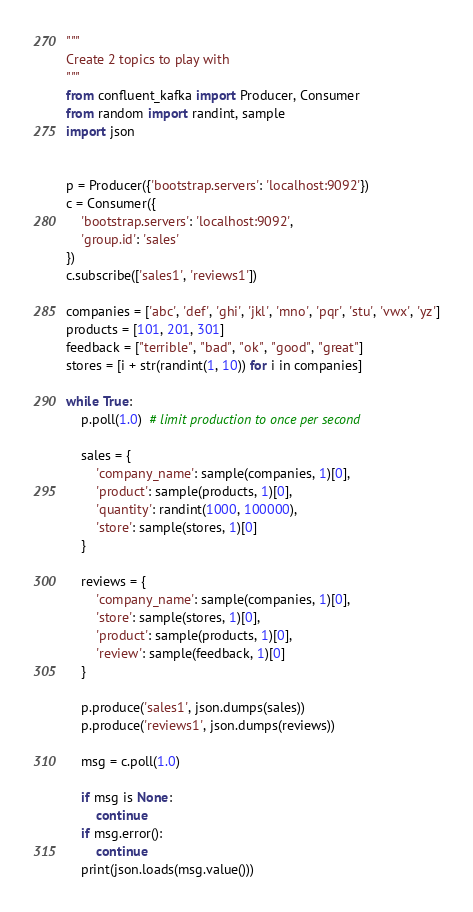Convert code to text. <code><loc_0><loc_0><loc_500><loc_500><_Python_>"""
Create 2 topics to play with
"""
from confluent_kafka import Producer, Consumer
from random import randint, sample
import json


p = Producer({'bootstrap.servers': 'localhost:9092'})
c = Consumer({
    'bootstrap.servers': 'localhost:9092',
    'group.id': 'sales'
})
c.subscribe(['sales1', 'reviews1'])

companies = ['abc', 'def', 'ghi', 'jkl', 'mno', 'pqr', 'stu', 'vwx', 'yz']
products = [101, 201, 301]
feedback = ["terrible", "bad", "ok", "good", "great"]
stores = [i + str(randint(1, 10)) for i in companies]

while True:
    p.poll(1.0)  # limit production to once per second

    sales = {
        'company_name': sample(companies, 1)[0],
        'product': sample(products, 1)[0],
        'quantity': randint(1000, 100000),
        'store': sample(stores, 1)[0]
    }

    reviews = {
        'company_name': sample(companies, 1)[0],
        'store': sample(stores, 1)[0],
        'product': sample(products, 1)[0],
        'review': sample(feedback, 1)[0]
    }

    p.produce('sales1', json.dumps(sales))
    p.produce('reviews1', json.dumps(reviews))

    msg = c.poll(1.0)

    if msg is None:
        continue
    if msg.error():
        continue
    print(json.loads(msg.value()))
</code> 